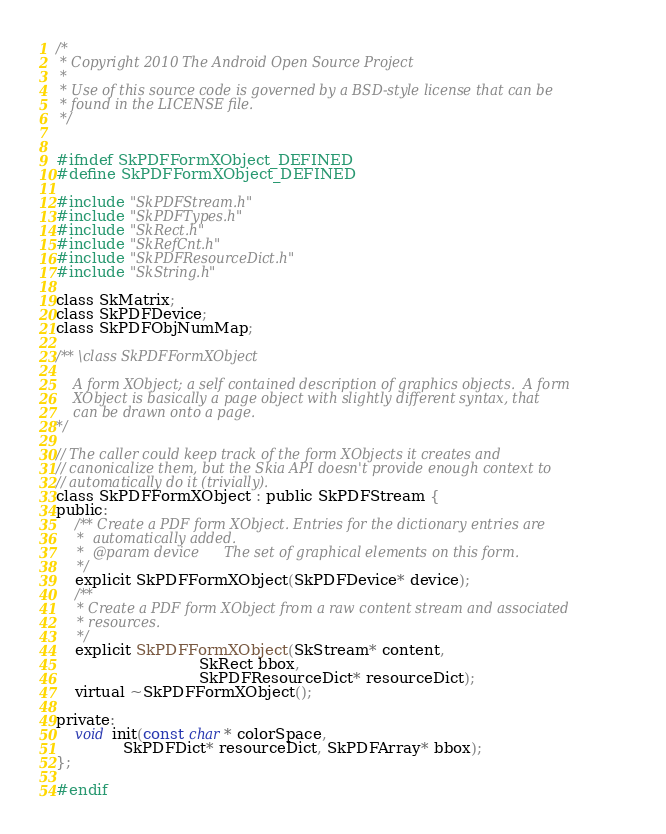<code> <loc_0><loc_0><loc_500><loc_500><_C_>
/*
 * Copyright 2010 The Android Open Source Project
 *
 * Use of this source code is governed by a BSD-style license that can be
 * found in the LICENSE file.
 */


#ifndef SkPDFFormXObject_DEFINED
#define SkPDFFormXObject_DEFINED

#include "SkPDFStream.h"
#include "SkPDFTypes.h"
#include "SkRect.h"
#include "SkRefCnt.h"
#include "SkPDFResourceDict.h"
#include "SkString.h"

class SkMatrix;
class SkPDFDevice;
class SkPDFObjNumMap;

/** \class SkPDFFormXObject

    A form XObject; a self contained description of graphics objects.  A form
    XObject is basically a page object with slightly different syntax, that
    can be drawn onto a page.
*/

// The caller could keep track of the form XObjects it creates and
// canonicalize them, but the Skia API doesn't provide enough context to
// automatically do it (trivially).
class SkPDFFormXObject : public SkPDFStream {
public:
    /** Create a PDF form XObject. Entries for the dictionary entries are
     *  automatically added.
     *  @param device      The set of graphical elements on this form.
     */
    explicit SkPDFFormXObject(SkPDFDevice* device);
    /**
     * Create a PDF form XObject from a raw content stream and associated
     * resources.
     */
    explicit SkPDFFormXObject(SkStream* content,
                              SkRect bbox,
                              SkPDFResourceDict* resourceDict);
    virtual ~SkPDFFormXObject();

private:
    void init(const char* colorSpace,
              SkPDFDict* resourceDict, SkPDFArray* bbox);
};

#endif
</code> 